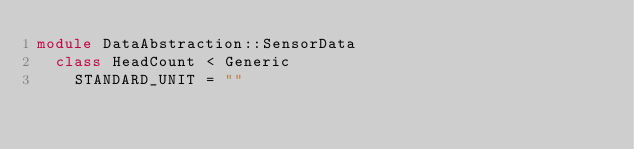<code> <loc_0><loc_0><loc_500><loc_500><_Ruby_>module DataAbstraction::SensorData
  class HeadCount < Generic
    STANDARD_UNIT = ""</code> 